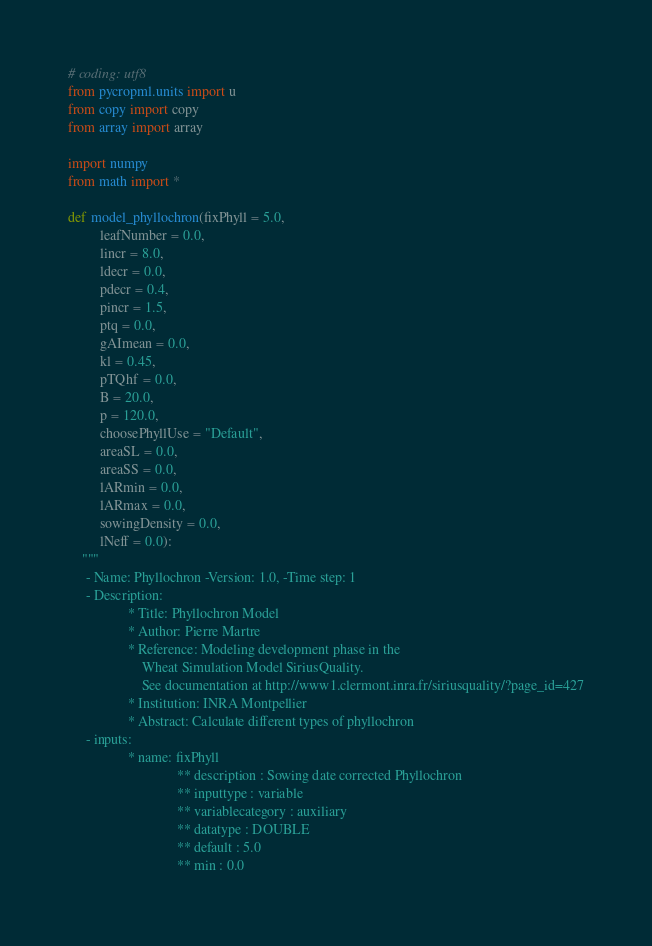<code> <loc_0><loc_0><loc_500><loc_500><_Python_># coding: utf8
from pycropml.units import u
from copy import copy
from array import array

import numpy
from math import *

def model_phyllochron(fixPhyll = 5.0,
         leafNumber = 0.0,
         lincr = 8.0,
         ldecr = 0.0,
         pdecr = 0.4,
         pincr = 1.5,
         ptq = 0.0,
         gAImean = 0.0,
         kl = 0.45,
         pTQhf = 0.0,
         B = 20.0,
         p = 120.0,
         choosePhyllUse = "Default",
         areaSL = 0.0,
         areaSS = 0.0,
         lARmin = 0.0,
         lARmax = 0.0,
         sowingDensity = 0.0,
         lNeff = 0.0):
    """
     - Name: Phyllochron -Version: 1.0, -Time step: 1
     - Description:
                 * Title: Phyllochron Model
                 * Author: Pierre Martre
                 * Reference: Modeling development phase in the 
                     Wheat Simulation Model SiriusQuality.
                     See documentation at http://www1.clermont.inra.fr/siriusquality/?page_id=427
                 * Institution: INRA Montpellier
                 * Abstract: Calculate different types of phyllochron 
     - inputs:
                 * name: fixPhyll
                               ** description : Sowing date corrected Phyllochron
                               ** inputtype : variable
                               ** variablecategory : auxiliary
                               ** datatype : DOUBLE
                               ** default : 5.0
                               ** min : 0.0</code> 